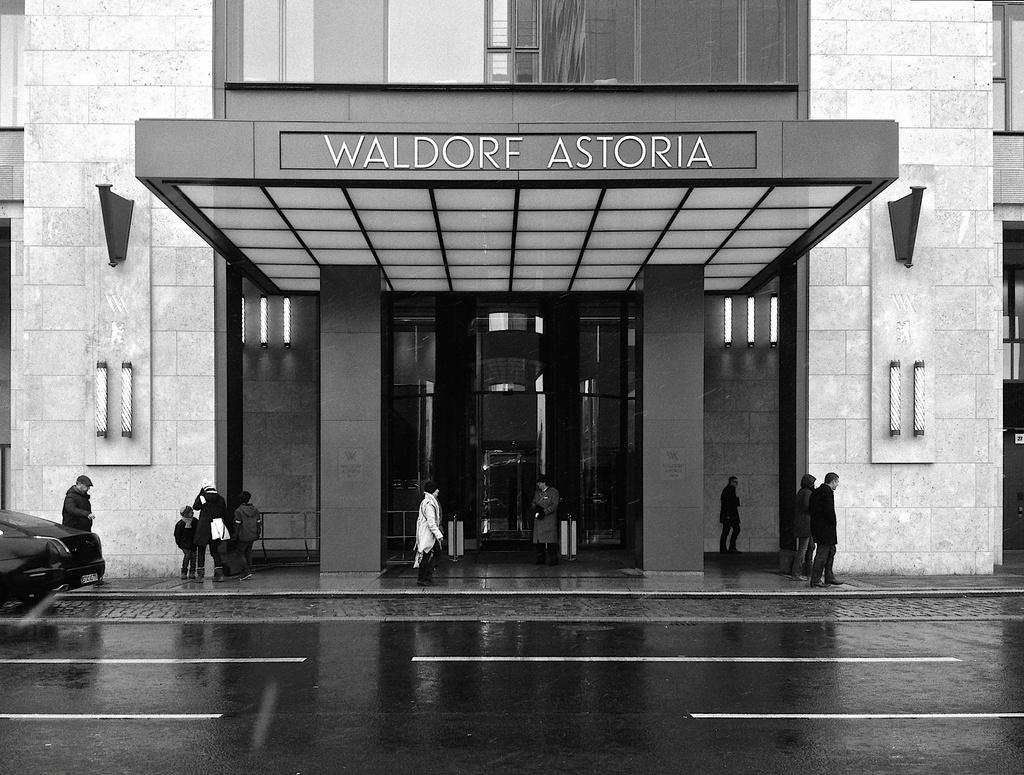How would you summarize this image in a sentence or two? It is a black and white picture. In this image, we can see people, vehicles, pillars, walls, lights, building, glass objects, name board and few things. At the bottom, there is a road. 